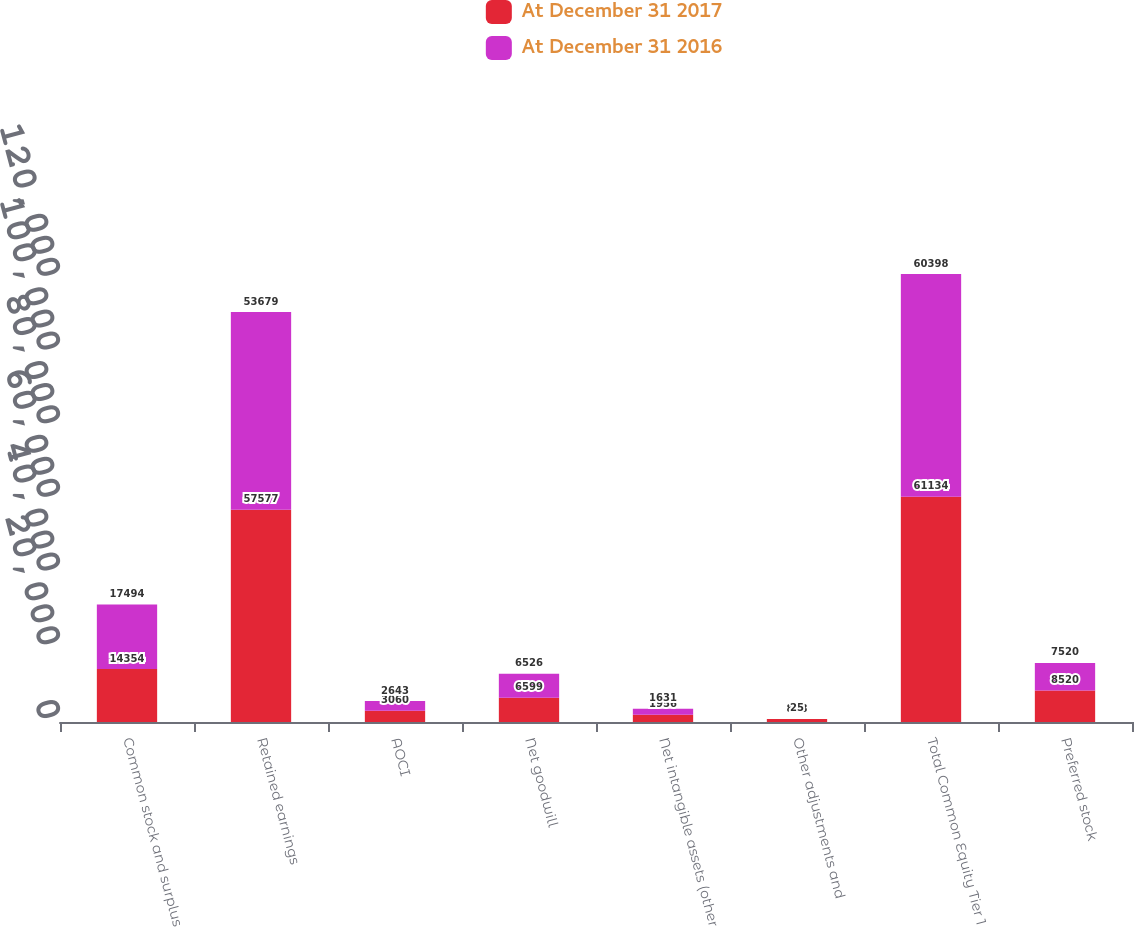Convert chart. <chart><loc_0><loc_0><loc_500><loc_500><stacked_bar_chart><ecel><fcel>Common stock and surplus<fcel>Retained earnings<fcel>AOCI<fcel>Net goodwill<fcel>Net intangible assets (other<fcel>Other adjustments and<fcel>Total Common Equity Tier 1<fcel>Preferred stock<nl><fcel>At December 31 2017<fcel>14354<fcel>57577<fcel>3060<fcel>6599<fcel>1956<fcel>818<fcel>61134<fcel>8520<nl><fcel>At December 31 2016<fcel>17494<fcel>53679<fcel>2643<fcel>6526<fcel>1631<fcel>25<fcel>60398<fcel>7520<nl></chart> 